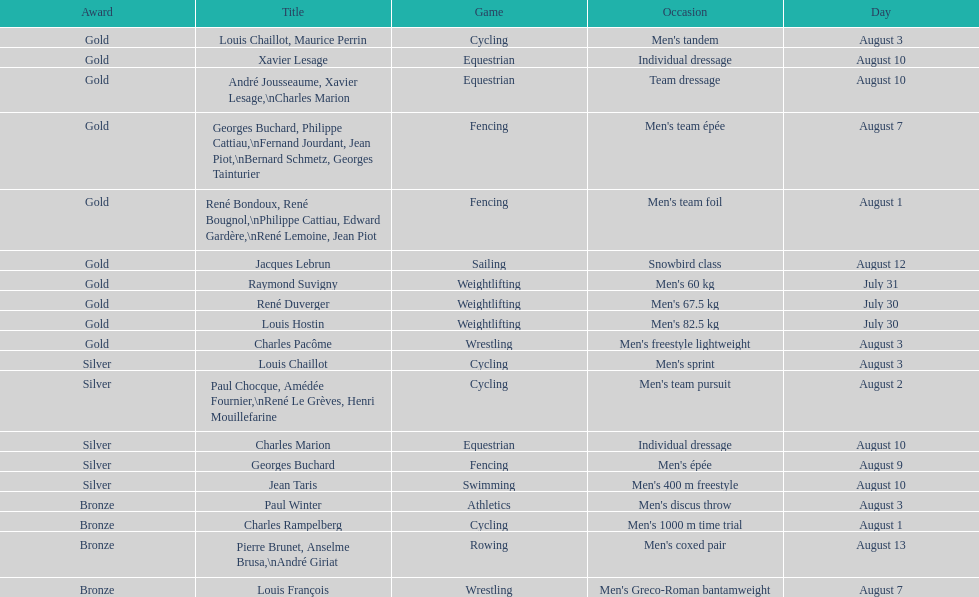After august 3, how many medals have been secured? 9. 